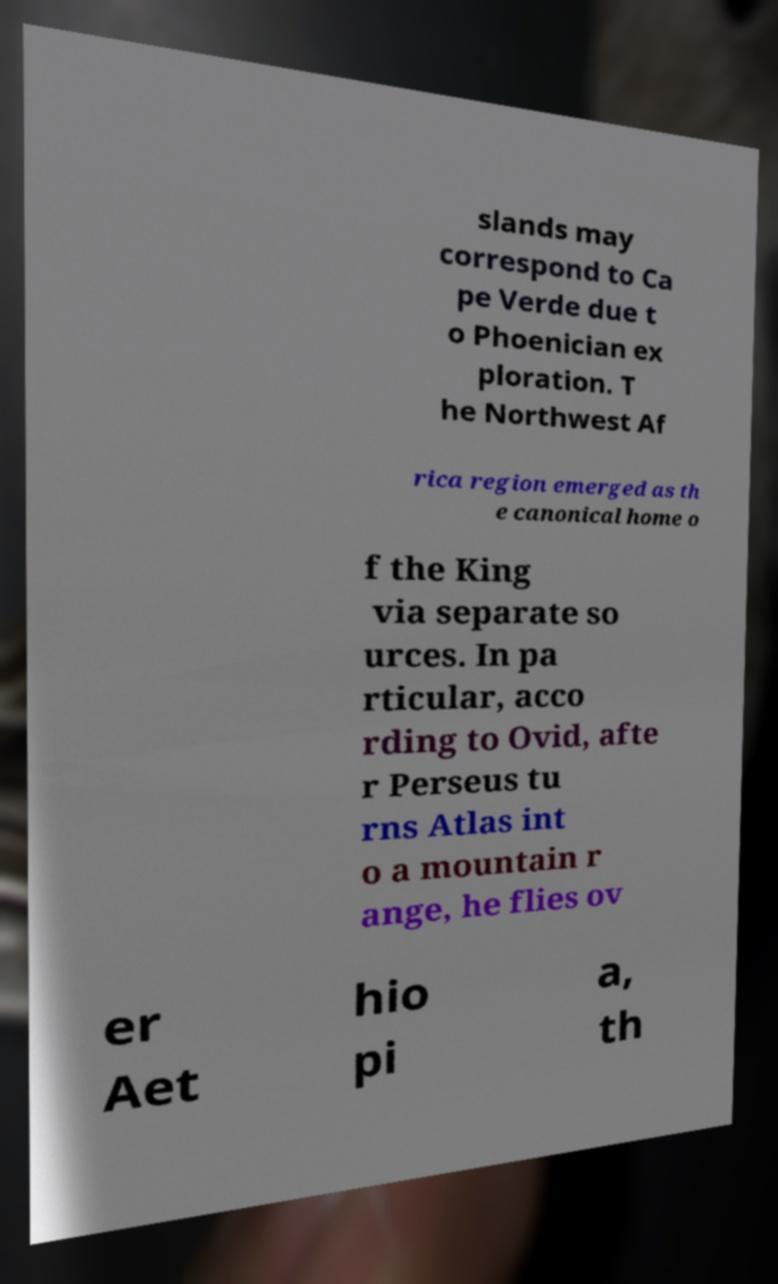What messages or text are displayed in this image? I need them in a readable, typed format. slands may correspond to Ca pe Verde due t o Phoenician ex ploration. T he Northwest Af rica region emerged as th e canonical home o f the King via separate so urces. In pa rticular, acco rding to Ovid, afte r Perseus tu rns Atlas int o a mountain r ange, he flies ov er Aet hio pi a, th 